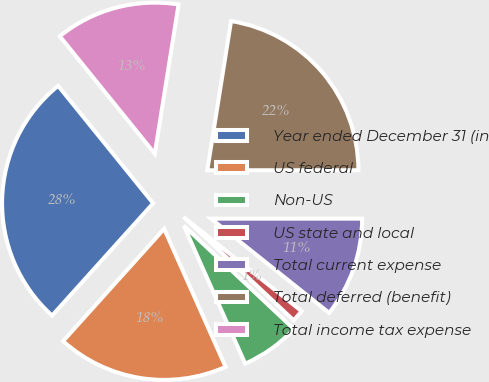Convert chart to OTSL. <chart><loc_0><loc_0><loc_500><loc_500><pie_chart><fcel>Year ended December 31 (in<fcel>US federal<fcel>Non-US<fcel>US state and local<fcel>Total current expense<fcel>Total deferred (benefit)<fcel>Total income tax expense<nl><fcel>27.51%<fcel>18.33%<fcel>6.34%<fcel>1.28%<fcel>10.72%<fcel>22.48%<fcel>13.34%<nl></chart> 